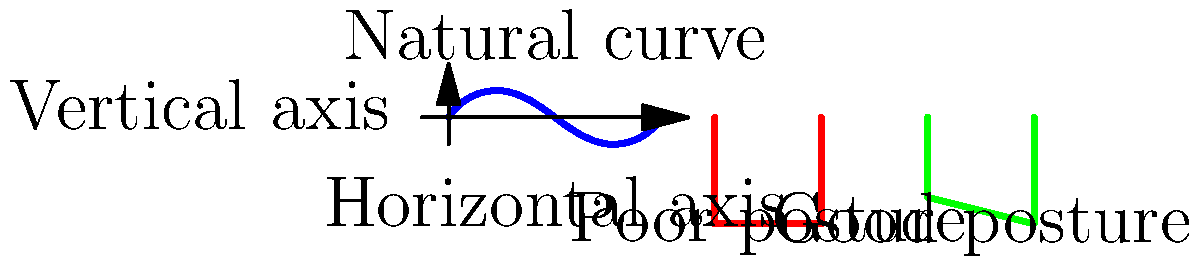Based on the diagram showing spinal curvature in different sitting positions, which posture is more likely to maintain the natural curve of the spine and potentially reduce the risk of back pain? To answer this question, let's analyze the diagram step-by-step:

1. The blue curve represents the natural curvature of the spine, which has a slight S-shape.

2. Two sitting positions are shown:
   a) The red outline (left) shows a slouched or poor posture.
   b) The green outline (right) shows a more upright or good posture.

3. Comparing the spine curves:
   a) The poor posture (red) shows a more pronounced curve, deviating significantly from the natural spine shape.
   b) The good posture (green) maintains a curve closer to the natural spine shape.

4. Scientific evidence suggests that maintaining a posture closer to the spine's natural curve reduces stress on the vertebrae, muscles, and ligaments.

5. The good posture (green) is more likely to:
   a) Distribute body weight more evenly
   b) Reduce unnecessary strain on supporting muscles and ligaments
   c) Minimize the risk of developing chronic back pain

6. While the study of biomechanics and ergonomics is ongoing, current research supports the benefits of maintaining a posture that closely mimics the spine's natural curve.

Therefore, the posture more likely to maintain the natural curve of the spine and potentially reduce the risk of back pain is the one represented by the green outline (good posture).
Answer: Good posture (green outline) 